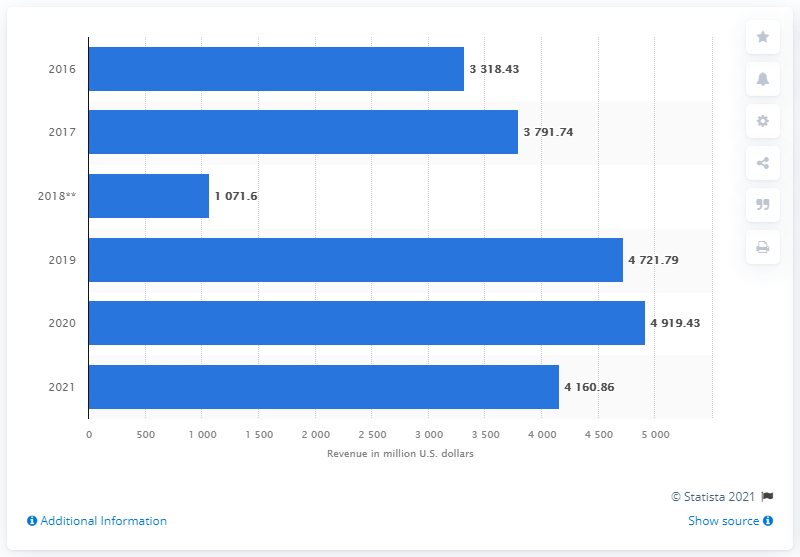Mention a couple of crucial points in this snapshot. In 2021, VF Corporation's active segment revenues were approximately $4,160.86. 